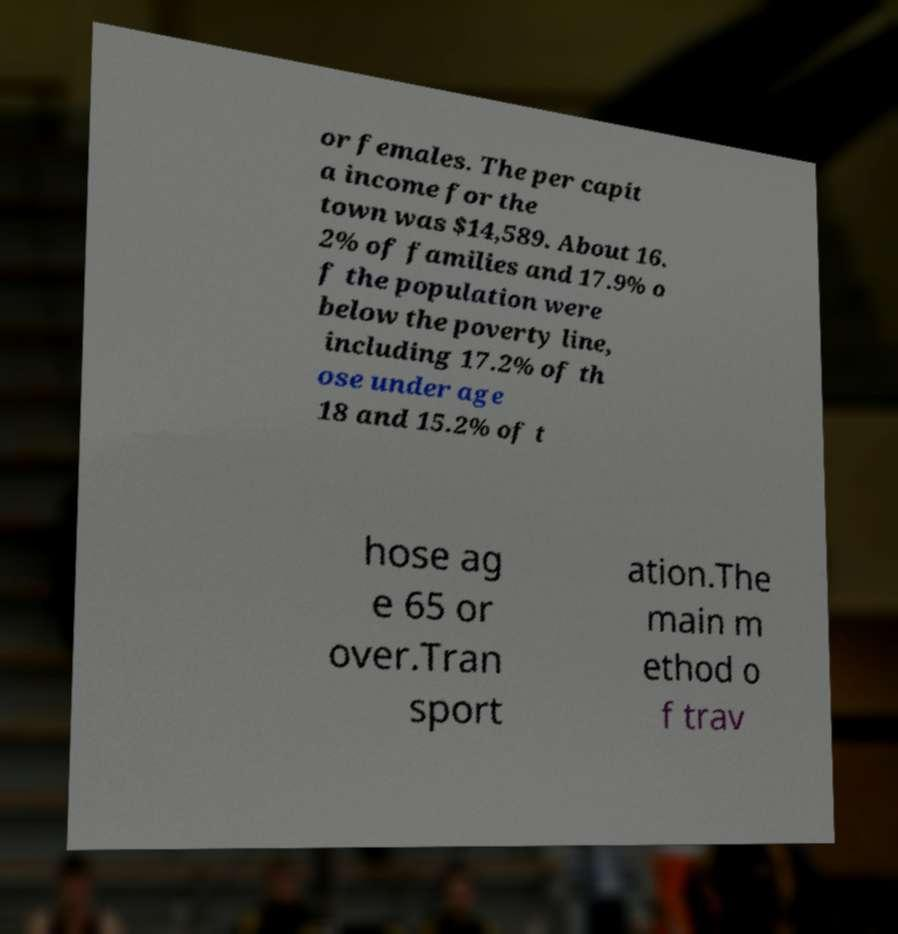Please read and relay the text visible in this image. What does it say? or females. The per capit a income for the town was $14,589. About 16. 2% of families and 17.9% o f the population were below the poverty line, including 17.2% of th ose under age 18 and 15.2% of t hose ag e 65 or over.Tran sport ation.The main m ethod o f trav 